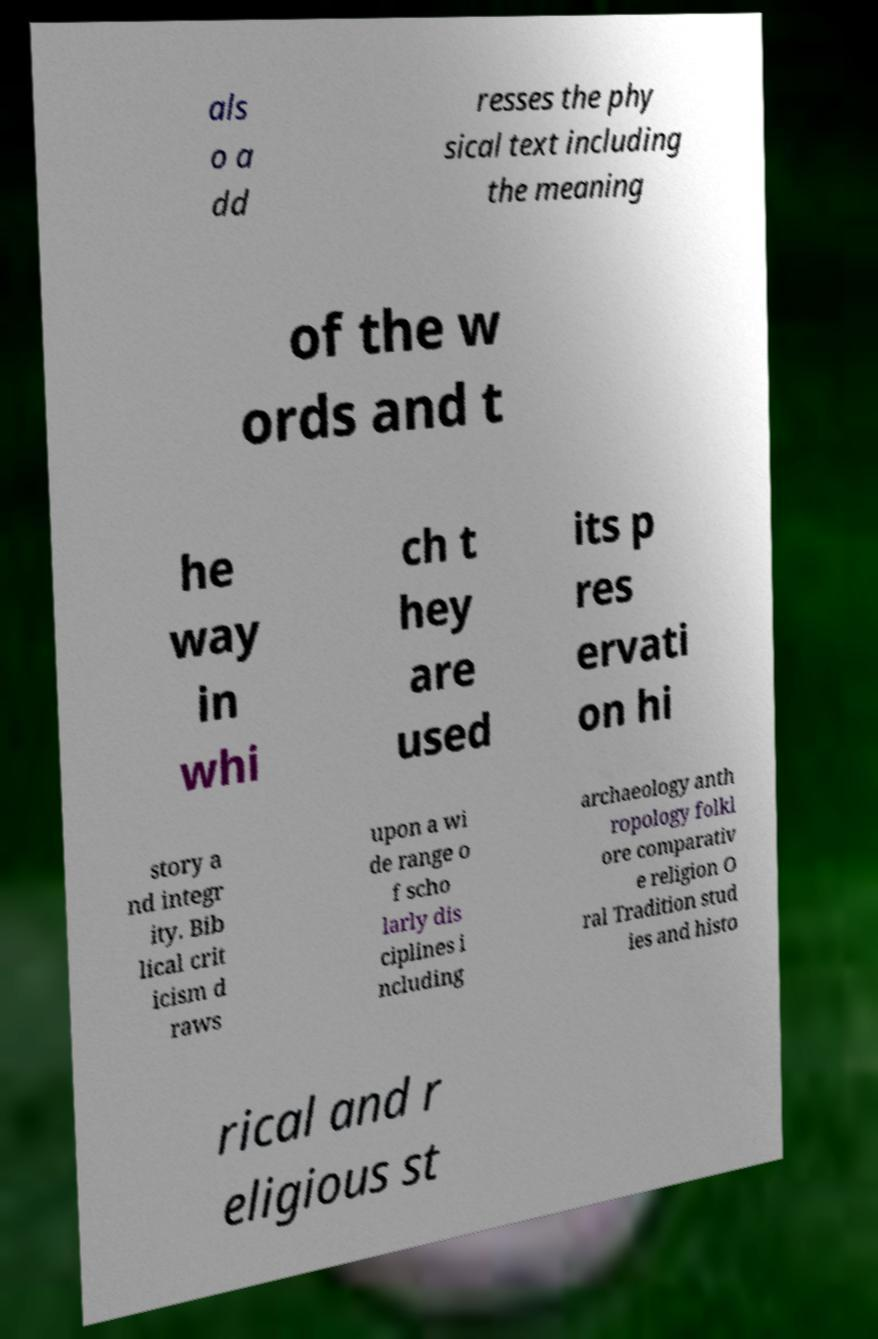Could you extract and type out the text from this image? als o a dd resses the phy sical text including the meaning of the w ords and t he way in whi ch t hey are used its p res ervati on hi story a nd integr ity. Bib lical crit icism d raws upon a wi de range o f scho larly dis ciplines i ncluding archaeology anth ropology folkl ore comparativ e religion O ral Tradition stud ies and histo rical and r eligious st 